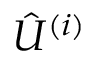<formula> <loc_0><loc_0><loc_500><loc_500>{ \hat { U } } ^ { ( i ) }</formula> 